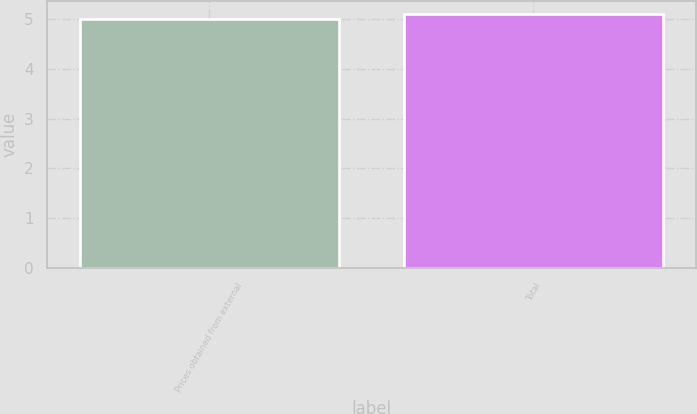<chart> <loc_0><loc_0><loc_500><loc_500><bar_chart><fcel>Prices obtained from external<fcel>Total<nl><fcel>5<fcel>5.1<nl></chart> 